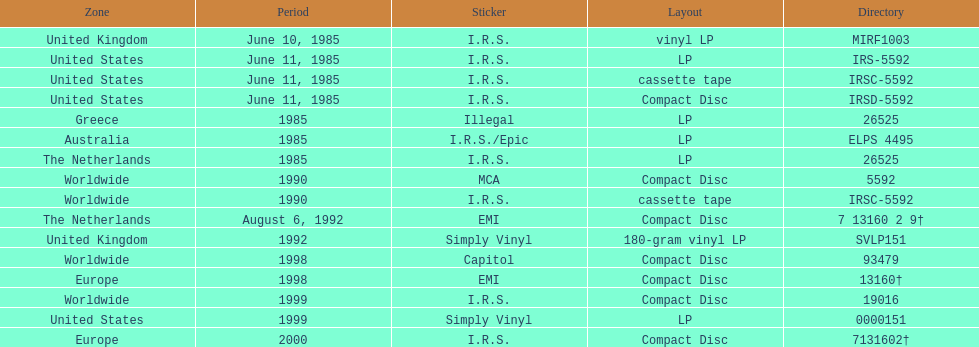What was the date of the first vinyl lp release? June 10, 1985. 